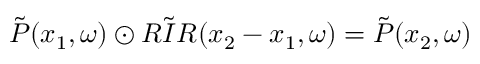<formula> <loc_0><loc_0><loc_500><loc_500>\tilde { P } ( x _ { 1 } , \omega ) \odot \tilde { R I R } ( x _ { 2 } - x _ { 1 } , \omega ) = \tilde { P } ( x _ { 2 } , \omega )</formula> 